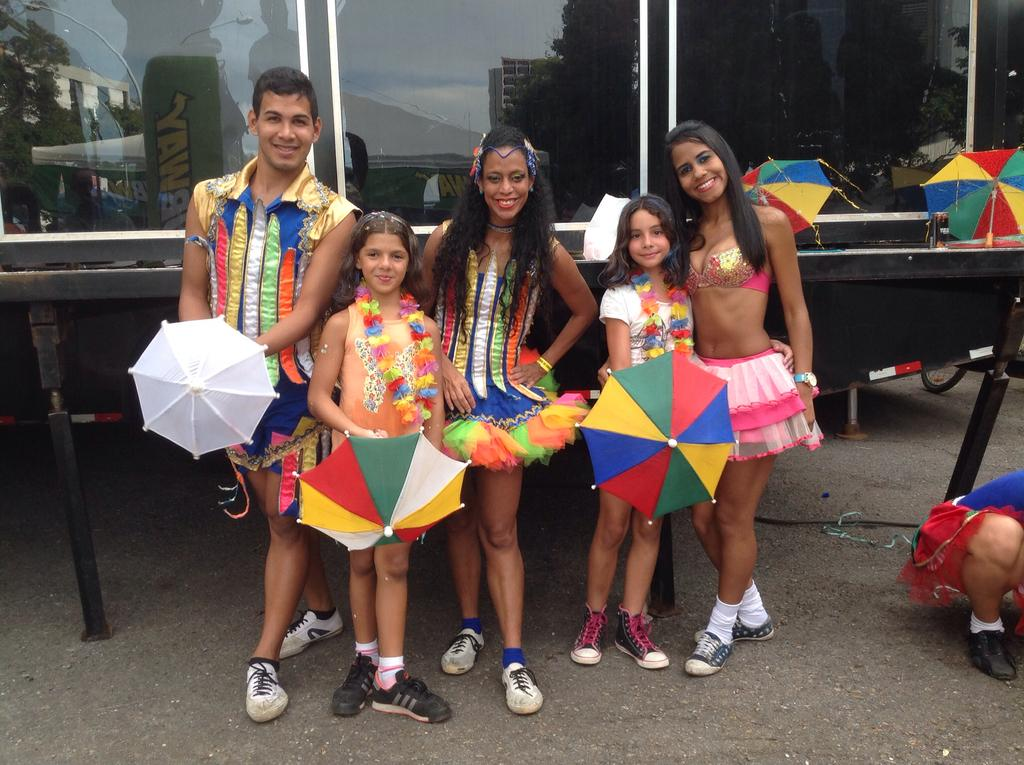What are the people in the image doing? The people in the image are standing and sitting. What objects are present to provide shade in the image? There are umbrellas in the image. What type of surface is visible beneath the people's feet in the image? There is grass in the image. What type of structure can be seen in the background of the image? There is a building in the image. What type of voice can be heard coming from the orange in the image? There is no orange present in the image, and therefore no voice can be heard from it. 